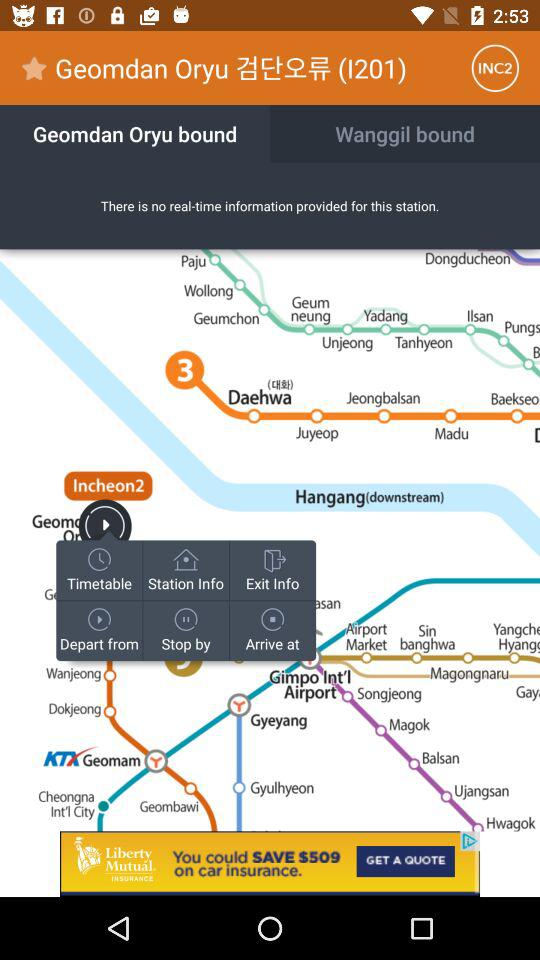Which apps are recommended?
When the provided information is insufficient, respond with <no answer>. <no answer> 